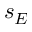Convert formula to latex. <formula><loc_0><loc_0><loc_500><loc_500>s _ { E }</formula> 